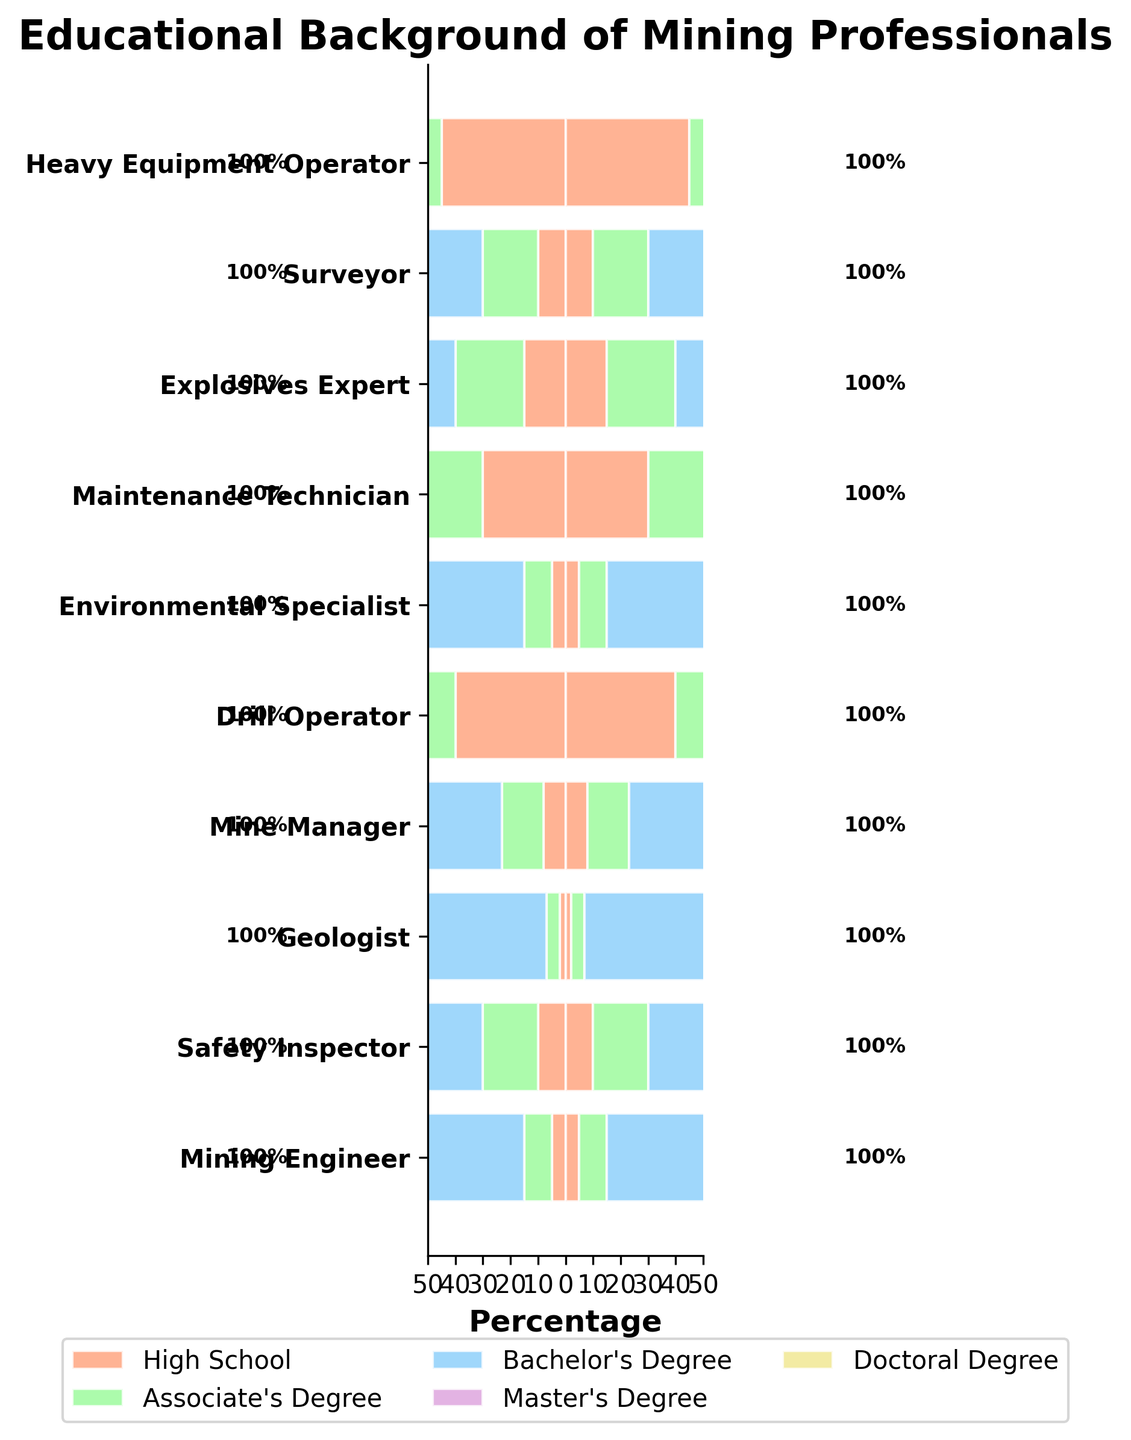How many job roles have Master's Degrees as part of their educational background? The bar graph shows educational categories, including Master's Degrees, for various job roles. We look at the Master's Degrees section and count the number of job roles represented.
Answer: 8 Which job role has the highest percentage of employees with a Doctoral Degree? Compare the lengths of the bars representing Doctoral Degrees for each job role. The Mining Engineer role and Geologist have the longest bars, but the Mining Engineer has the highest at 10%.
Answer: Mining Engineer What is the total percentage of Heavy Equipment Operators with High School and Associate's Degrees? Add the percentages of Heavy Equipment Operators with High School (45%) and Associate's Degrees (35%).
Answer: 80% Which job role has the smallest proportion of Bachelor's Degrees? Look at the Bachelor's Degree bars for all job roles and identify the shortest one, which is for the Drill Operator (20%).
Answer: Drill Operator Between Environmental Specialists and Safety Inspectors, who has a higher percentage of Bachelor's Degrees? Compare the lengths of the Bachelor's Degree bars between Environmental Specialists (55%) and Safety Inspectors (50%).
Answer: Environmental Specialist What percentage of Drill Operators have postgraduate degrees (Master's or Doctoral)? Add the percentage of Drill Operators with Master's Degrees (5%) and Doctoral Degrees (0%).
Answer: 5% Which job role shows an equal percentage for Bachelor's and Master's Degrees? Look for job roles where the bars for Bachelor's and Master's Degrees are of equal length. The Mine Manager has 40% Bachelor's and 35% Master's, which is not equal, so the answer is none.
Answer: None What is the combined percentage of Safety Inspectors with an Associate's or higher degree? The percentage of Safety Inspectors with an Associate's Degree is 20%, plus Bachelor's (50%), Master's (18%), and Doctoral (2%), resulting in a total sum of 90%.
Answer: 90% Who has a higher percentage of Associate's Degrees, Maintenance Technicians or Explosives Experts? Compare the lengths of the Associate's Degree bars for Maintenance Technicians (40%) and Explosives Experts (25%).
Answer: Maintenance Technicians How does the percentage of Bachelor's Degrees compare between Surveyors and Mine Managers? The Surveyors have 50% with Bachelor's Degrees, and Mine Managers have 40%. Compare these two percentages.
Answer: Surveyors (50%) have a higher percentage than Mine Managers (40%) 